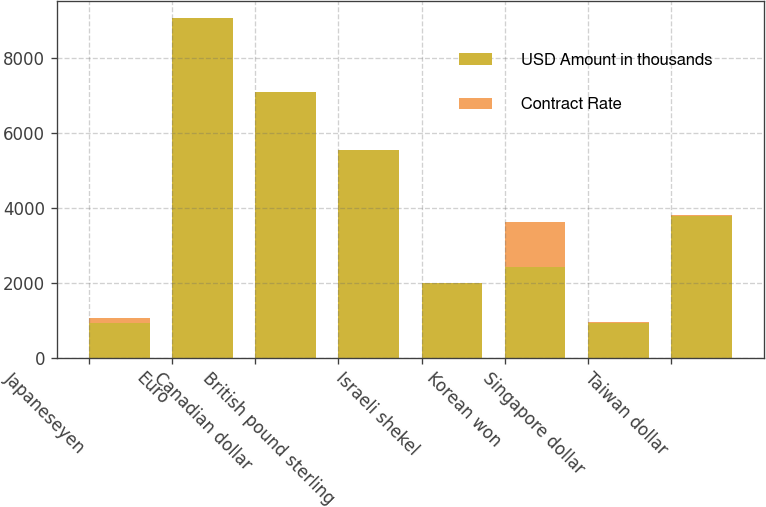Convert chart. <chart><loc_0><loc_0><loc_500><loc_500><stacked_bar_chart><ecel><fcel>Japaneseyen<fcel>Euro<fcel>Canadian dollar<fcel>British pound sterling<fcel>Israeli shekel<fcel>Korean won<fcel>Singapore dollar<fcel>Taiwan dollar<nl><fcel>USD Amount in thousands<fcel>936<fcel>9062<fcel>7084<fcel>5531<fcel>1986<fcel>2419<fcel>936<fcel>3784<nl><fcel>Contract Rate<fcel>109.23<fcel>0.86<fcel>1.32<fcel>0.59<fcel>4.5<fcel>1190<fcel>1.75<fcel>33.96<nl></chart> 